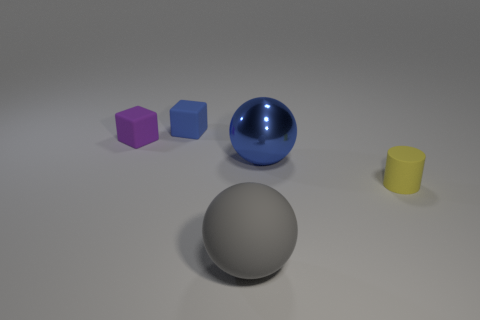Are there any rubber blocks that have the same color as the tiny matte cylinder?
Provide a succinct answer. No. Is there a big yellow matte cube?
Your answer should be compact. No. There is a cube that is left of the blue cube; is it the same size as the tiny blue matte object?
Your answer should be very brief. Yes. Are there fewer small purple shiny balls than yellow cylinders?
Offer a very short reply. Yes. The blue object that is left of the big sphere that is behind the tiny object to the right of the blue cube is what shape?
Your answer should be very brief. Cube. Is there another cube made of the same material as the purple block?
Offer a terse response. Yes. Does the large object that is behind the tiny cylinder have the same color as the rubber sphere in front of the tiny cylinder?
Offer a very short reply. No. Are there fewer rubber cylinders on the right side of the tiny purple rubber thing than large rubber balls?
Ensure brevity in your answer.  No. What number of objects are large purple balls or large balls in front of the large metal ball?
Provide a succinct answer. 1. The cylinder that is made of the same material as the small purple block is what color?
Your answer should be very brief. Yellow. 